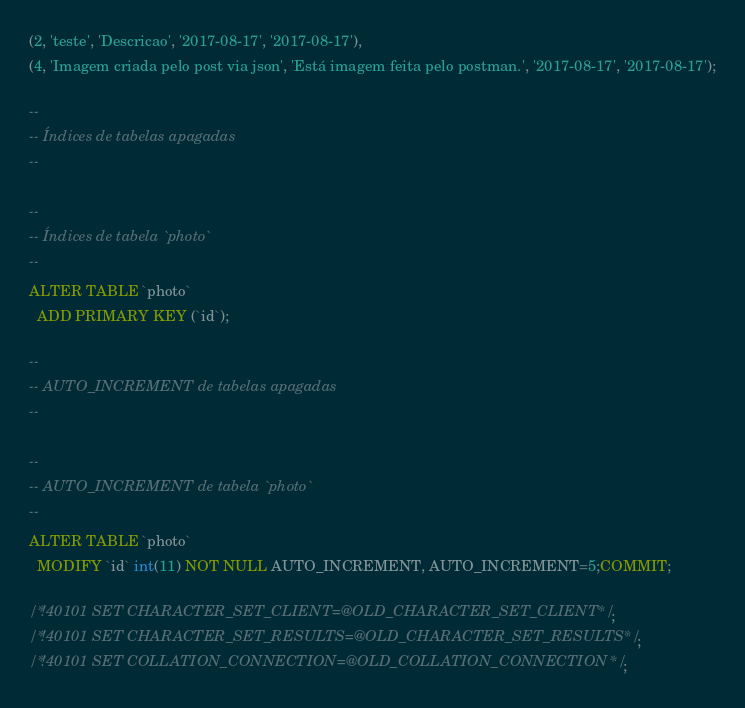Convert code to text. <code><loc_0><loc_0><loc_500><loc_500><_SQL_>(2, 'teste', 'Descricao', '2017-08-17', '2017-08-17'),
(4, 'Imagem criada pelo post via json', 'Está imagem feita pelo postman.', '2017-08-17', '2017-08-17');

--
-- Índices de tabelas apagadas
--

--
-- Índices de tabela `photo`
--
ALTER TABLE `photo`
  ADD PRIMARY KEY (`id`);

--
-- AUTO_INCREMENT de tabelas apagadas
--

--
-- AUTO_INCREMENT de tabela `photo`
--
ALTER TABLE `photo`
  MODIFY `id` int(11) NOT NULL AUTO_INCREMENT, AUTO_INCREMENT=5;COMMIT;

/*!40101 SET CHARACTER_SET_CLIENT=@OLD_CHARACTER_SET_CLIENT */;
/*!40101 SET CHARACTER_SET_RESULTS=@OLD_CHARACTER_SET_RESULTS */;
/*!40101 SET COLLATION_CONNECTION=@OLD_COLLATION_CONNECTION */;
</code> 